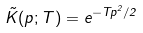<formula> <loc_0><loc_0><loc_500><loc_500>\tilde { K } ( p ; T ) = e ^ { - T p ^ { 2 } / 2 }</formula> 